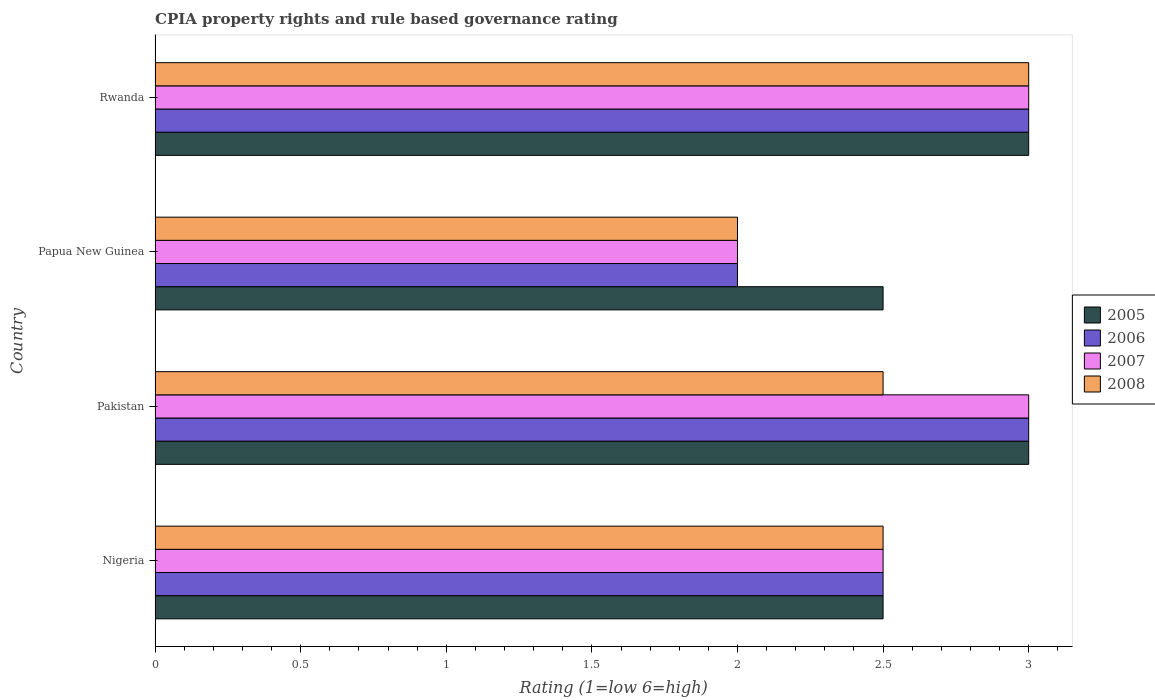How many different coloured bars are there?
Your answer should be very brief. 4. How many groups of bars are there?
Your answer should be compact. 4. Are the number of bars per tick equal to the number of legend labels?
Your answer should be very brief. Yes. Are the number of bars on each tick of the Y-axis equal?
Keep it short and to the point. Yes. How many bars are there on the 2nd tick from the top?
Your answer should be compact. 4. How many bars are there on the 2nd tick from the bottom?
Offer a very short reply. 4. What is the label of the 3rd group of bars from the top?
Ensure brevity in your answer.  Pakistan. In how many cases, is the number of bars for a given country not equal to the number of legend labels?
Make the answer very short. 0. Across all countries, what is the maximum CPIA rating in 2006?
Keep it short and to the point. 3. In which country was the CPIA rating in 2008 minimum?
Your response must be concise. Papua New Guinea. What is the total CPIA rating in 2006 in the graph?
Your answer should be compact. 10.5. What is the difference between the CPIA rating in 2008 in Nigeria and the CPIA rating in 2007 in Papua New Guinea?
Make the answer very short. 0.5. What is the average CPIA rating in 2006 per country?
Ensure brevity in your answer.  2.62. What is the ratio of the CPIA rating in 2005 in Nigeria to that in Pakistan?
Offer a very short reply. 0.83. Is the difference between the CPIA rating in 2007 in Pakistan and Rwanda greater than the difference between the CPIA rating in 2008 in Pakistan and Rwanda?
Your answer should be compact. Yes. Is the sum of the CPIA rating in 2006 in Pakistan and Rwanda greater than the maximum CPIA rating in 2008 across all countries?
Keep it short and to the point. Yes. Are all the bars in the graph horizontal?
Provide a succinct answer. Yes. How many countries are there in the graph?
Offer a terse response. 4. What is the difference between two consecutive major ticks on the X-axis?
Your answer should be compact. 0.5. Does the graph contain any zero values?
Your response must be concise. No. Where does the legend appear in the graph?
Ensure brevity in your answer.  Center right. How many legend labels are there?
Give a very brief answer. 4. What is the title of the graph?
Give a very brief answer. CPIA property rights and rule based governance rating. Does "2009" appear as one of the legend labels in the graph?
Keep it short and to the point. No. What is the label or title of the X-axis?
Your response must be concise. Rating (1=low 6=high). What is the label or title of the Y-axis?
Provide a short and direct response. Country. What is the Rating (1=low 6=high) of 2005 in Nigeria?
Your answer should be very brief. 2.5. What is the Rating (1=low 6=high) of 2007 in Nigeria?
Make the answer very short. 2.5. What is the Rating (1=low 6=high) in 2005 in Pakistan?
Your answer should be compact. 3. What is the Rating (1=low 6=high) of 2006 in Pakistan?
Your answer should be very brief. 3. What is the Rating (1=low 6=high) in 2008 in Pakistan?
Provide a succinct answer. 2.5. What is the Rating (1=low 6=high) of 2005 in Rwanda?
Your answer should be very brief. 3. What is the Rating (1=low 6=high) of 2006 in Rwanda?
Your answer should be very brief. 3. What is the Rating (1=low 6=high) of 2007 in Rwanda?
Your answer should be very brief. 3. What is the Rating (1=low 6=high) of 2008 in Rwanda?
Offer a terse response. 3. Across all countries, what is the maximum Rating (1=low 6=high) in 2005?
Make the answer very short. 3. Across all countries, what is the maximum Rating (1=low 6=high) of 2007?
Provide a short and direct response. 3. Across all countries, what is the minimum Rating (1=low 6=high) of 2005?
Provide a succinct answer. 2.5. Across all countries, what is the minimum Rating (1=low 6=high) in 2007?
Your answer should be very brief. 2. Across all countries, what is the minimum Rating (1=low 6=high) in 2008?
Your response must be concise. 2. What is the total Rating (1=low 6=high) in 2005 in the graph?
Offer a very short reply. 11. What is the total Rating (1=low 6=high) of 2006 in the graph?
Your answer should be very brief. 10.5. What is the total Rating (1=low 6=high) of 2008 in the graph?
Your answer should be very brief. 10. What is the difference between the Rating (1=low 6=high) in 2007 in Nigeria and that in Pakistan?
Offer a terse response. -0.5. What is the difference between the Rating (1=low 6=high) of 2005 in Nigeria and that in Papua New Guinea?
Provide a short and direct response. 0. What is the difference between the Rating (1=low 6=high) of 2006 in Nigeria and that in Papua New Guinea?
Provide a succinct answer. 0.5. What is the difference between the Rating (1=low 6=high) of 2007 in Nigeria and that in Papua New Guinea?
Make the answer very short. 0.5. What is the difference between the Rating (1=low 6=high) in 2005 in Nigeria and that in Rwanda?
Your answer should be very brief. -0.5. What is the difference between the Rating (1=low 6=high) in 2006 in Nigeria and that in Rwanda?
Ensure brevity in your answer.  -0.5. What is the difference between the Rating (1=low 6=high) in 2007 in Nigeria and that in Rwanda?
Make the answer very short. -0.5. What is the difference between the Rating (1=low 6=high) in 2008 in Nigeria and that in Rwanda?
Offer a terse response. -0.5. What is the difference between the Rating (1=low 6=high) of 2005 in Pakistan and that in Papua New Guinea?
Make the answer very short. 0.5. What is the difference between the Rating (1=low 6=high) of 2006 in Pakistan and that in Papua New Guinea?
Provide a succinct answer. 1. What is the difference between the Rating (1=low 6=high) of 2005 in Pakistan and that in Rwanda?
Provide a short and direct response. 0. What is the difference between the Rating (1=low 6=high) in 2005 in Papua New Guinea and that in Rwanda?
Provide a succinct answer. -0.5. What is the difference between the Rating (1=low 6=high) in 2006 in Papua New Guinea and that in Rwanda?
Your answer should be very brief. -1. What is the difference between the Rating (1=low 6=high) in 2008 in Papua New Guinea and that in Rwanda?
Provide a short and direct response. -1. What is the difference between the Rating (1=low 6=high) in 2005 in Nigeria and the Rating (1=low 6=high) in 2006 in Pakistan?
Offer a very short reply. -0.5. What is the difference between the Rating (1=low 6=high) in 2005 in Nigeria and the Rating (1=low 6=high) in 2008 in Pakistan?
Keep it short and to the point. 0. What is the difference between the Rating (1=low 6=high) of 2006 in Nigeria and the Rating (1=low 6=high) of 2008 in Pakistan?
Your answer should be compact. 0. What is the difference between the Rating (1=low 6=high) of 2005 in Nigeria and the Rating (1=low 6=high) of 2007 in Papua New Guinea?
Provide a succinct answer. 0.5. What is the difference between the Rating (1=low 6=high) of 2007 in Nigeria and the Rating (1=low 6=high) of 2008 in Papua New Guinea?
Provide a succinct answer. 0.5. What is the difference between the Rating (1=low 6=high) of 2005 in Nigeria and the Rating (1=low 6=high) of 2007 in Rwanda?
Your answer should be compact. -0.5. What is the difference between the Rating (1=low 6=high) in 2005 in Nigeria and the Rating (1=low 6=high) in 2008 in Rwanda?
Your answer should be very brief. -0.5. What is the difference between the Rating (1=low 6=high) in 2006 in Nigeria and the Rating (1=low 6=high) in 2008 in Rwanda?
Offer a terse response. -0.5. What is the difference between the Rating (1=low 6=high) of 2005 in Pakistan and the Rating (1=low 6=high) of 2006 in Papua New Guinea?
Ensure brevity in your answer.  1. What is the difference between the Rating (1=low 6=high) in 2005 in Pakistan and the Rating (1=low 6=high) in 2008 in Papua New Guinea?
Offer a very short reply. 1. What is the difference between the Rating (1=low 6=high) of 2006 in Pakistan and the Rating (1=low 6=high) of 2007 in Papua New Guinea?
Your answer should be compact. 1. What is the difference between the Rating (1=low 6=high) of 2006 in Pakistan and the Rating (1=low 6=high) of 2008 in Papua New Guinea?
Offer a very short reply. 1. What is the difference between the Rating (1=low 6=high) in 2007 in Pakistan and the Rating (1=low 6=high) in 2008 in Papua New Guinea?
Give a very brief answer. 1. What is the difference between the Rating (1=low 6=high) of 2005 in Pakistan and the Rating (1=low 6=high) of 2006 in Rwanda?
Your response must be concise. 0. What is the difference between the Rating (1=low 6=high) of 2005 in Pakistan and the Rating (1=low 6=high) of 2008 in Rwanda?
Keep it short and to the point. 0. What is the difference between the Rating (1=low 6=high) of 2005 in Papua New Guinea and the Rating (1=low 6=high) of 2006 in Rwanda?
Provide a succinct answer. -0.5. What is the difference between the Rating (1=low 6=high) in 2006 in Papua New Guinea and the Rating (1=low 6=high) in 2008 in Rwanda?
Provide a short and direct response. -1. What is the difference between the Rating (1=low 6=high) in 2007 in Papua New Guinea and the Rating (1=low 6=high) in 2008 in Rwanda?
Offer a very short reply. -1. What is the average Rating (1=low 6=high) in 2005 per country?
Ensure brevity in your answer.  2.75. What is the average Rating (1=low 6=high) of 2006 per country?
Your answer should be very brief. 2.62. What is the average Rating (1=low 6=high) of 2007 per country?
Provide a short and direct response. 2.62. What is the difference between the Rating (1=low 6=high) in 2005 and Rating (1=low 6=high) in 2006 in Nigeria?
Provide a short and direct response. 0. What is the difference between the Rating (1=low 6=high) of 2005 and Rating (1=low 6=high) of 2007 in Nigeria?
Give a very brief answer. 0. What is the difference between the Rating (1=low 6=high) of 2006 and Rating (1=low 6=high) of 2007 in Nigeria?
Offer a very short reply. 0. What is the difference between the Rating (1=low 6=high) of 2007 and Rating (1=low 6=high) of 2008 in Nigeria?
Make the answer very short. 0. What is the difference between the Rating (1=low 6=high) in 2005 and Rating (1=low 6=high) in 2007 in Pakistan?
Your answer should be very brief. 0. What is the difference between the Rating (1=low 6=high) in 2005 and Rating (1=low 6=high) in 2008 in Pakistan?
Your answer should be compact. 0.5. What is the difference between the Rating (1=low 6=high) of 2006 and Rating (1=low 6=high) of 2007 in Pakistan?
Ensure brevity in your answer.  0. What is the difference between the Rating (1=low 6=high) in 2006 and Rating (1=low 6=high) in 2008 in Pakistan?
Offer a very short reply. 0.5. What is the difference between the Rating (1=low 6=high) of 2007 and Rating (1=low 6=high) of 2008 in Pakistan?
Your answer should be very brief. 0.5. What is the difference between the Rating (1=low 6=high) in 2005 and Rating (1=low 6=high) in 2007 in Papua New Guinea?
Provide a succinct answer. 0.5. What is the difference between the Rating (1=low 6=high) in 2006 and Rating (1=low 6=high) in 2007 in Papua New Guinea?
Provide a short and direct response. 0. What is the difference between the Rating (1=low 6=high) of 2006 and Rating (1=low 6=high) of 2008 in Papua New Guinea?
Make the answer very short. 0. What is the difference between the Rating (1=low 6=high) in 2007 and Rating (1=low 6=high) in 2008 in Papua New Guinea?
Your answer should be compact. 0. What is the difference between the Rating (1=low 6=high) of 2005 and Rating (1=low 6=high) of 2008 in Rwanda?
Your response must be concise. 0. What is the difference between the Rating (1=low 6=high) in 2006 and Rating (1=low 6=high) in 2007 in Rwanda?
Your answer should be compact. 0. What is the difference between the Rating (1=low 6=high) in 2006 and Rating (1=low 6=high) in 2008 in Rwanda?
Provide a short and direct response. 0. What is the ratio of the Rating (1=low 6=high) in 2005 in Nigeria to that in Pakistan?
Your answer should be compact. 0.83. What is the ratio of the Rating (1=low 6=high) in 2007 in Nigeria to that in Pakistan?
Your answer should be very brief. 0.83. What is the ratio of the Rating (1=low 6=high) in 2008 in Nigeria to that in Pakistan?
Your response must be concise. 1. What is the ratio of the Rating (1=low 6=high) of 2005 in Nigeria to that in Papua New Guinea?
Give a very brief answer. 1. What is the ratio of the Rating (1=low 6=high) of 2006 in Nigeria to that in Rwanda?
Ensure brevity in your answer.  0.83. What is the ratio of the Rating (1=low 6=high) in 2008 in Nigeria to that in Rwanda?
Provide a succinct answer. 0.83. What is the ratio of the Rating (1=low 6=high) in 2005 in Pakistan to that in Papua New Guinea?
Ensure brevity in your answer.  1.2. What is the ratio of the Rating (1=low 6=high) in 2006 in Pakistan to that in Papua New Guinea?
Keep it short and to the point. 1.5. What is the ratio of the Rating (1=low 6=high) of 2008 in Pakistan to that in Papua New Guinea?
Give a very brief answer. 1.25. What is the ratio of the Rating (1=low 6=high) in 2007 in Pakistan to that in Rwanda?
Offer a terse response. 1. What is the ratio of the Rating (1=low 6=high) of 2008 in Pakistan to that in Rwanda?
Provide a short and direct response. 0.83. What is the ratio of the Rating (1=low 6=high) in 2006 in Papua New Guinea to that in Rwanda?
Your answer should be very brief. 0.67. What is the difference between the highest and the second highest Rating (1=low 6=high) in 2005?
Provide a succinct answer. 0. What is the difference between the highest and the second highest Rating (1=low 6=high) in 2007?
Give a very brief answer. 0. What is the difference between the highest and the lowest Rating (1=low 6=high) in 2007?
Keep it short and to the point. 1. 